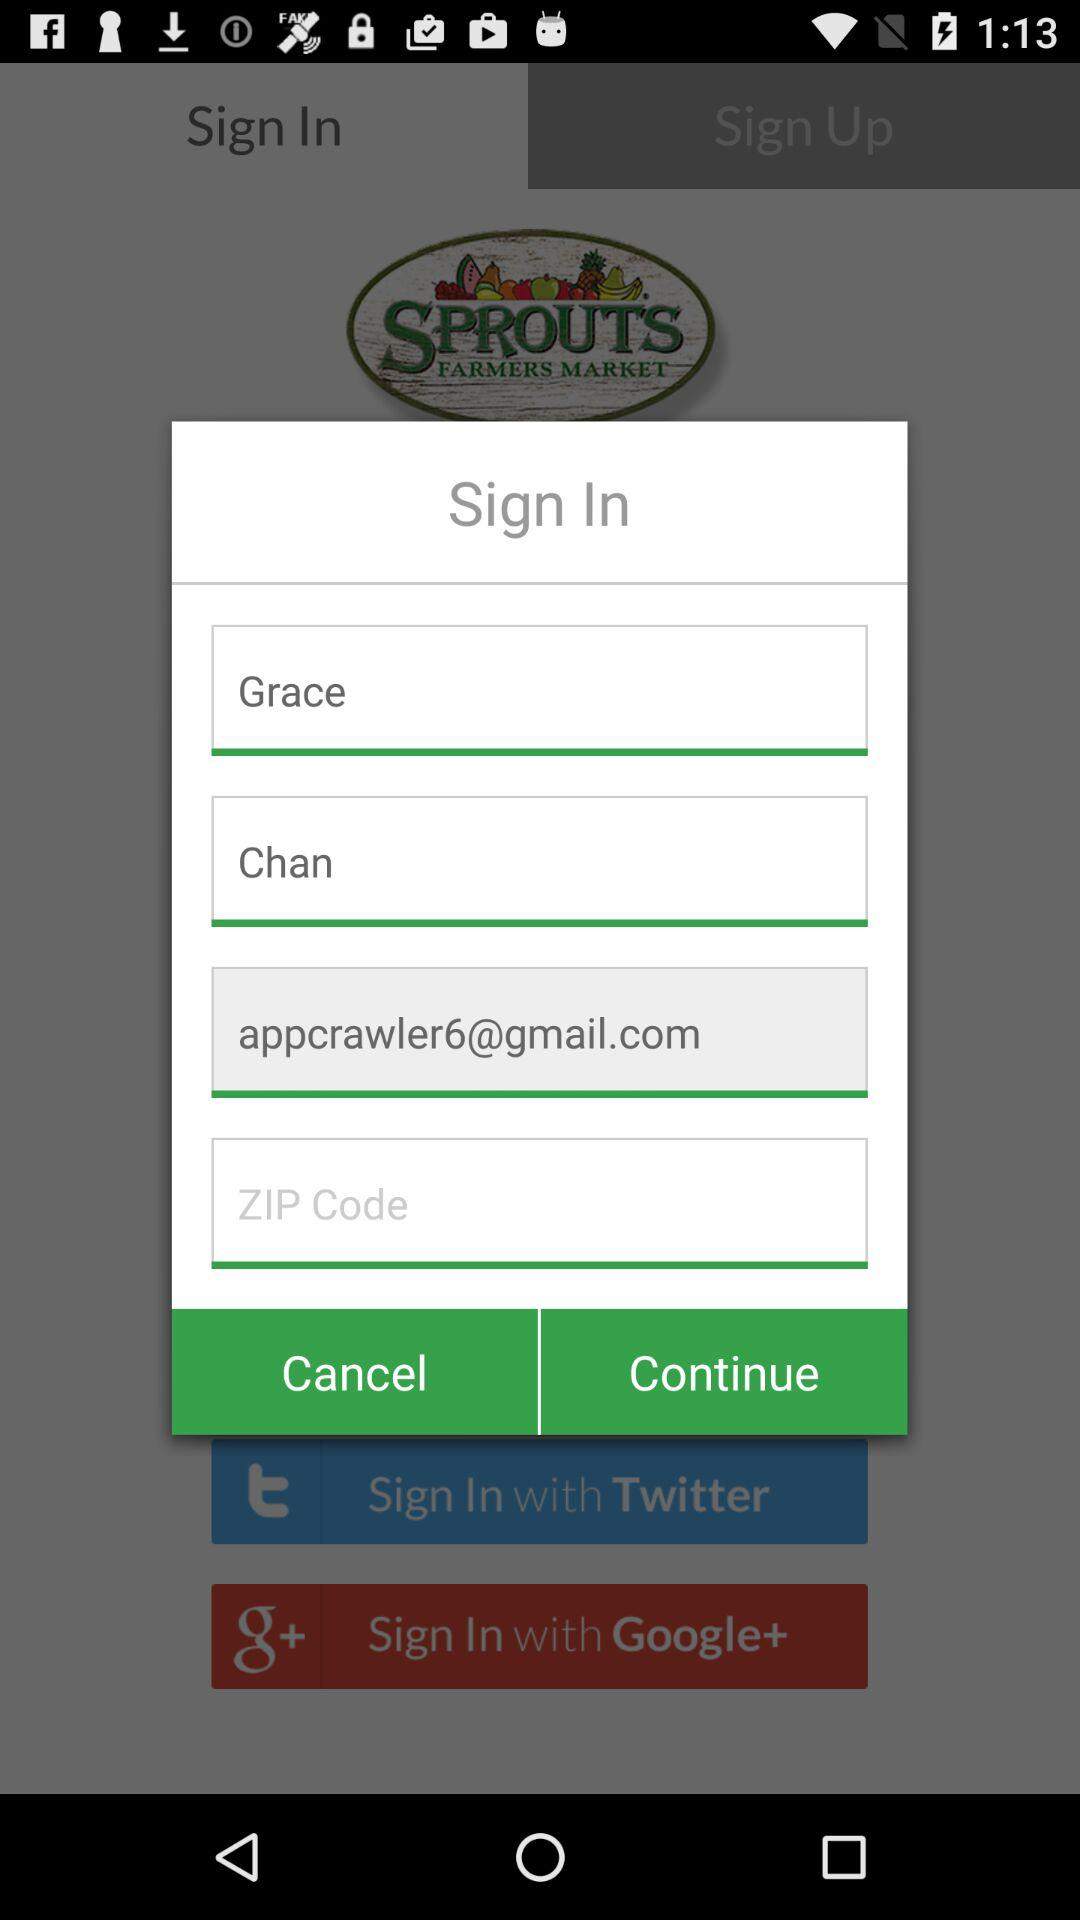What is the first name? The first name is Grace. 